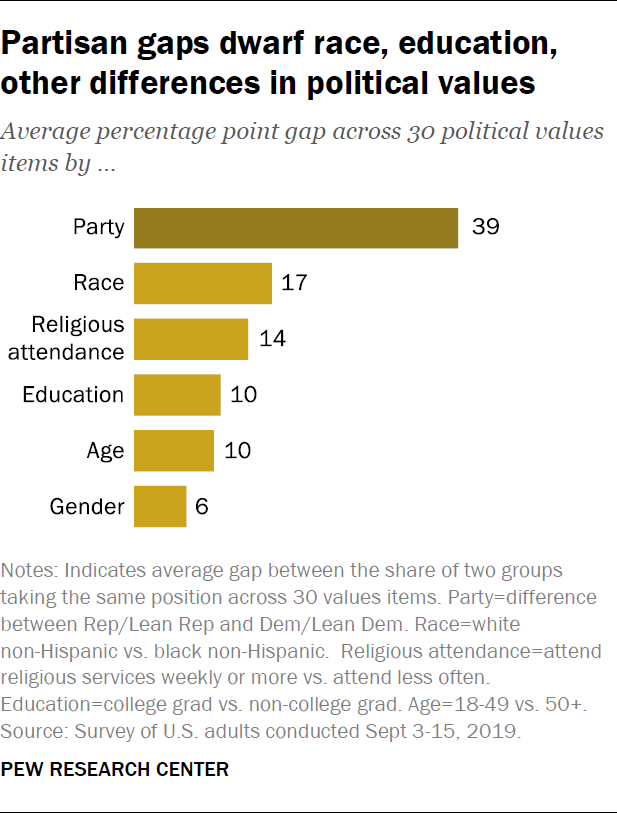Indicate a few pertinent items in this graphic. There is at least one pair of bars that have similar values. The color of the Party bar is different from that of all the other bars. 